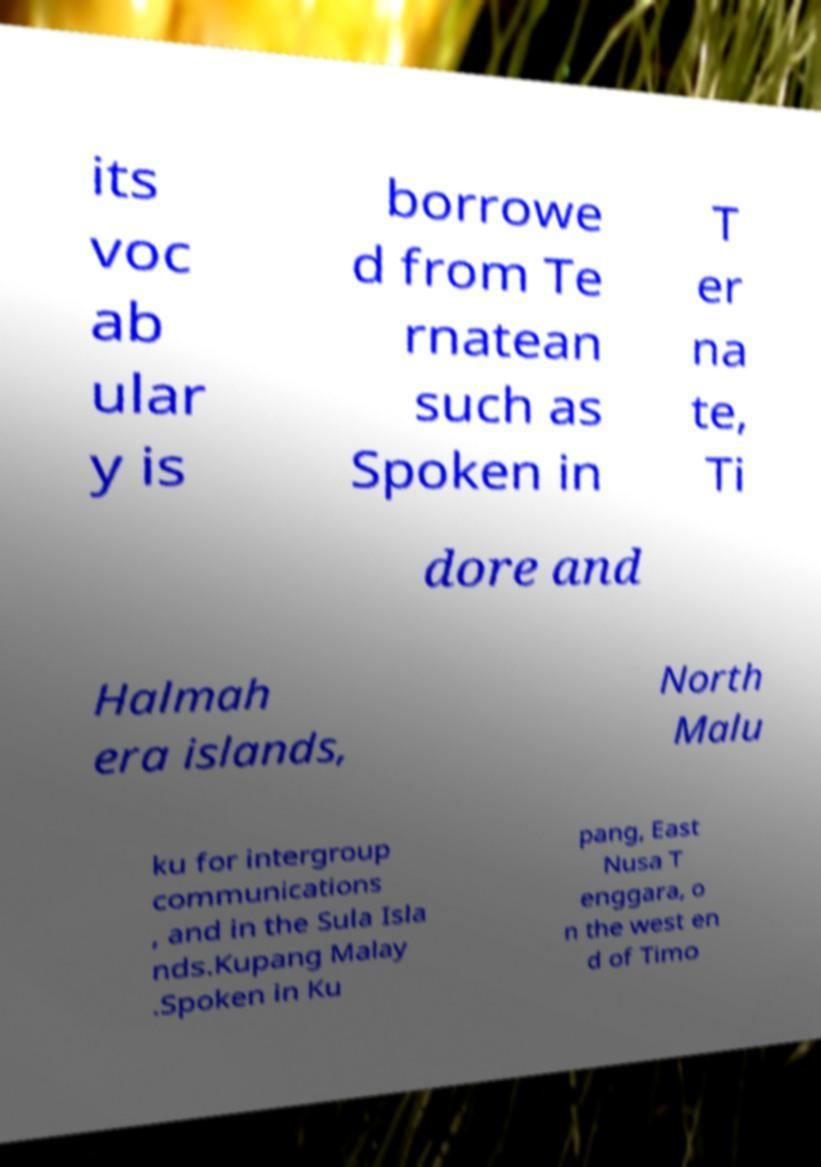Can you accurately transcribe the text from the provided image for me? its voc ab ular y is borrowe d from Te rnatean such as Spoken in T er na te, Ti dore and Halmah era islands, North Malu ku for intergroup communications , and in the Sula Isla nds.Kupang Malay .Spoken in Ku pang, East Nusa T enggara, o n the west en d of Timo 